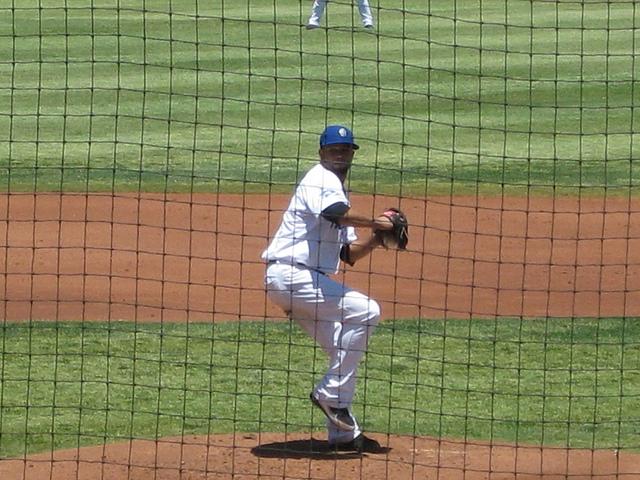How many players can be seen?
Short answer required. 2. What position does he play?
Keep it brief. Pitcher. What game is he playing?
Write a very short answer. Baseball. What number of squares make up the mesh behind the catcher?
Be succinct. Unknown. What kind of material is the glove made out of?
Give a very brief answer. Leather. 